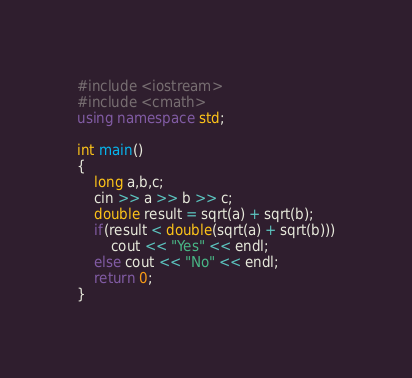Convert code to text. <code><loc_0><loc_0><loc_500><loc_500><_C++_>#include <iostream>
#include <cmath>
using namespace std;

int main()
{
	long a,b,c;
  	cin >> a >> b >> c;
	double result = sqrt(a) + sqrt(b);
  	if(result < double(sqrt(a) + sqrt(b)))
		cout << "Yes" << endl;
	else cout << "No" << endl;
	return 0;
}
</code> 